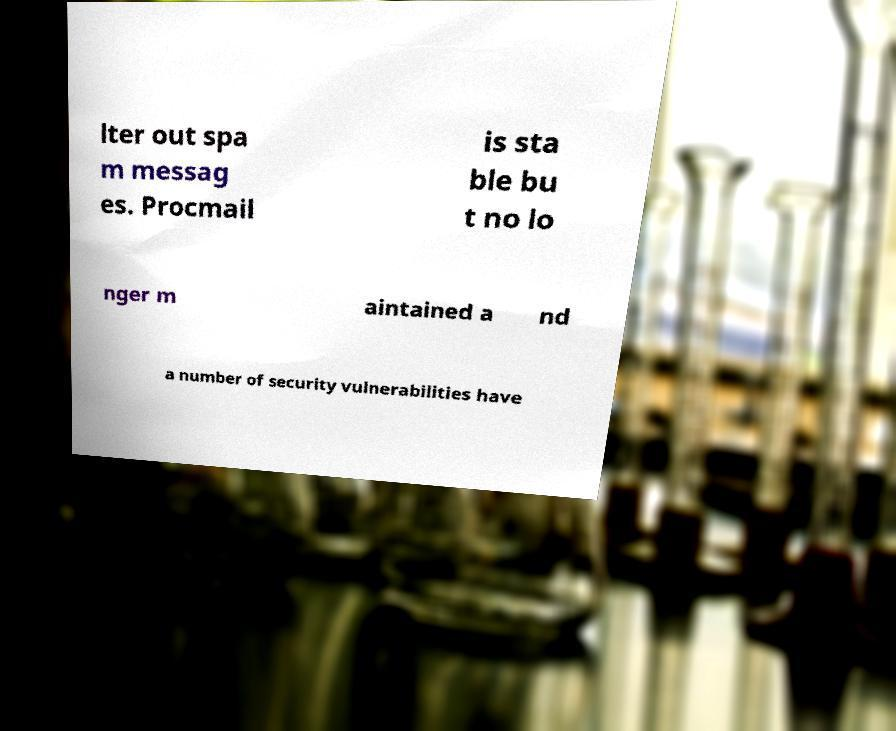For documentation purposes, I need the text within this image transcribed. Could you provide that? lter out spa m messag es. Procmail is sta ble bu t no lo nger m aintained a nd a number of security vulnerabilities have 